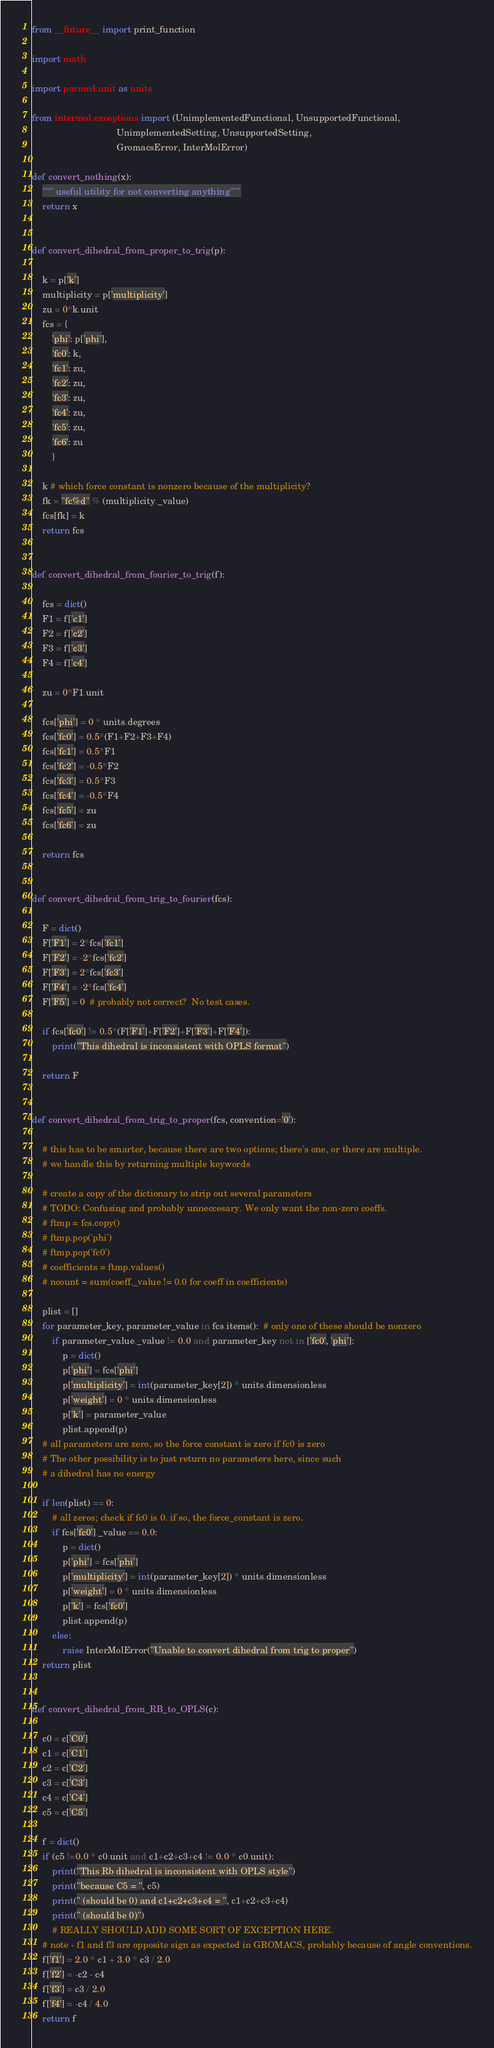Convert code to text. <code><loc_0><loc_0><loc_500><loc_500><_Python_>from __future__ import print_function

import math

import parmed.unit as units

from intermol.exceptions import (UnimplementedFunctional, UnsupportedFunctional,
                                 UnimplementedSetting, UnsupportedSetting,
                                 GromacsError, InterMolError)

def convert_nothing(x):
    """ useful utility for not converting anything"""
    return x


def convert_dihedral_from_proper_to_trig(p):

    k = p['k']
    multiplicity = p['multiplicity']
    zu = 0*k.unit
    fcs = {
        'phi': p['phi'],
        'fc0': k,
        'fc1': zu,
        'fc2': zu,
        'fc3': zu,
        'fc4': zu,
        'fc5': zu,
        'fc6': zu
        }

    k # which force constant is nonzero because of the multiplicity?
    fk = "fc%d" % (multiplicity._value)
    fcs[fk] = k
    return fcs


def convert_dihedral_from_fourier_to_trig(f):

    fcs = dict()
    F1 = f['c1']
    F2 = f['c2']
    F3 = f['c3']
    F4 = f['c4']

    zu = 0*F1.unit

    fcs['phi'] = 0 * units.degrees
    fcs['fc0'] = 0.5*(F1+F2+F3+F4)
    fcs['fc1'] = 0.5*F1
    fcs['fc2'] = -0.5*F2
    fcs['fc3'] = 0.5*F3
    fcs['fc4'] = -0.5*F4
    fcs['fc5'] = zu
    fcs['fc6'] = zu

    return fcs


def convert_dihedral_from_trig_to_fourier(fcs):

    F = dict()
    F['F1'] = 2*fcs['fc1']
    F['F2'] = -2*fcs['fc2']
    F['F3'] = 2*fcs['fc3']
    F['F4'] = -2*fcs['fc4']
    F['F5'] = 0  # probably not correct?  No test cases.

    if fcs['fc0'] != 0.5*(F['F1']+F['F2']+F['F3']+F['F4']):
        print("This dihedral is inconsistent with OPLS format")

    return F


def convert_dihedral_from_trig_to_proper(fcs, convention='0'):

    # this has to be smarter, because there are two options; there's one, or there are multiple.
    # we handle this by returning multiple keywords

    # create a copy of the dictionary to strip out several parameters
    # TODO: Confusing and probably unneccesary. We only want the non-zero coeffs.
    # ftmp = fcs.copy()
    # ftmp.pop('phi')
    # ftmp.pop('fc0')
    # coefficients = ftmp.values()
    # ncount = sum(coeff._value != 0.0 for coeff in coefficients)

    plist = []
    for parameter_key, parameter_value in fcs.items():  # only one of these should be nonzero
        if parameter_value._value != 0.0 and parameter_key not in ['fc0', 'phi']:
            p = dict()
            p['phi'] = fcs['phi']
            p['multiplicity'] = int(parameter_key[2]) * units.dimensionless
            p['weight'] = 0 * units.dimensionless
            p['k'] = parameter_value
            plist.append(p)
    # all parameters are zero, so the force constant is zero if fc0 is zero
    # The other possibility is to just return no parameters here, since such
    # a dihedral has no energy

    if len(plist) == 0:
        # all zeros; check if fc0 is 0. if so, the force_constant is zero.
        if fcs['fc0']._value == 0.0:
            p = dict()
            p['phi'] = fcs['phi']
            p['multiplicity'] = int(parameter_key[2]) * units.dimensionless
            p['weight'] = 0 * units.dimensionless
            p['k'] = fcs['fc0']
            plist.append(p)
        else:
            raise InterMolError("Unable to convert dihedral from trig to proper")
    return plist


def convert_dihedral_from_RB_to_OPLS(c):

    c0 = c['C0']
    c1 = c['C1']
    c2 = c['C2']
    c3 = c['C3']
    c4 = c['C4']
    c5 = c['C5']

    f = dict()
    if (c5 !=0.0 * c0.unit and c1+c2+c3+c4 != 0.0 * c0.unit):
        print("This Rb dihedral is inconsistent with OPLS style")
        print("because C5 = ", c5)
        print(" (should be 0) and c1+c2+c3+c4 = ", c1+c2+c3+c4)
        print(" (should be 0)")
        # REALLY SHOULD ADD SOME SORT OF EXCEPTION HERE.
    # note - f1 and f3 are opposite sign as expected in GROMACS, probably because of angle conventions.
    f['f1'] = 2.0 * c1 + 3.0 * c3 / 2.0
    f['f2'] = -c2 - c4
    f['f3'] = c3 / 2.0
    f['f4'] = -c4 / 4.0
    return f

</code> 